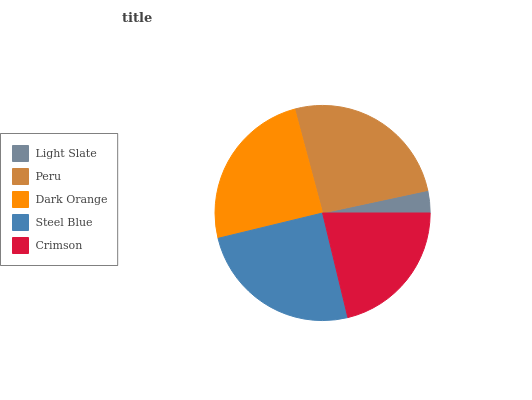Is Light Slate the minimum?
Answer yes or no. Yes. Is Peru the maximum?
Answer yes or no. Yes. Is Dark Orange the minimum?
Answer yes or no. No. Is Dark Orange the maximum?
Answer yes or no. No. Is Peru greater than Dark Orange?
Answer yes or no. Yes. Is Dark Orange less than Peru?
Answer yes or no. Yes. Is Dark Orange greater than Peru?
Answer yes or no. No. Is Peru less than Dark Orange?
Answer yes or no. No. Is Dark Orange the high median?
Answer yes or no. Yes. Is Dark Orange the low median?
Answer yes or no. Yes. Is Light Slate the high median?
Answer yes or no. No. Is Light Slate the low median?
Answer yes or no. No. 